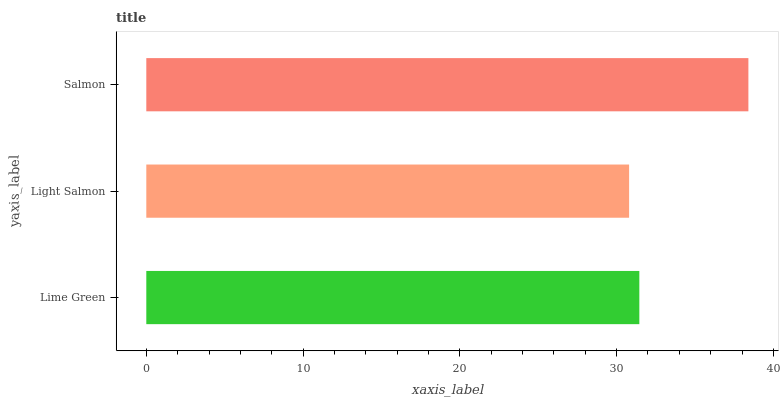Is Light Salmon the minimum?
Answer yes or no. Yes. Is Salmon the maximum?
Answer yes or no. Yes. Is Salmon the minimum?
Answer yes or no. No. Is Light Salmon the maximum?
Answer yes or no. No. Is Salmon greater than Light Salmon?
Answer yes or no. Yes. Is Light Salmon less than Salmon?
Answer yes or no. Yes. Is Light Salmon greater than Salmon?
Answer yes or no. No. Is Salmon less than Light Salmon?
Answer yes or no. No. Is Lime Green the high median?
Answer yes or no. Yes. Is Lime Green the low median?
Answer yes or no. Yes. Is Light Salmon the high median?
Answer yes or no. No. Is Light Salmon the low median?
Answer yes or no. No. 